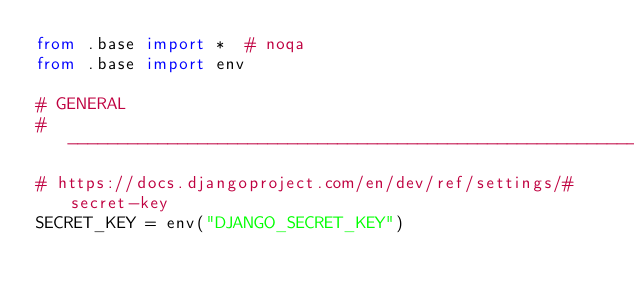Convert code to text. <code><loc_0><loc_0><loc_500><loc_500><_Python_>from .base import *  # noqa
from .base import env

# GENERAL
# ------------------------------------------------------------------------------
# https://docs.djangoproject.com/en/dev/ref/settings/#secret-key
SECRET_KEY = env("DJANGO_SECRET_KEY")</code> 